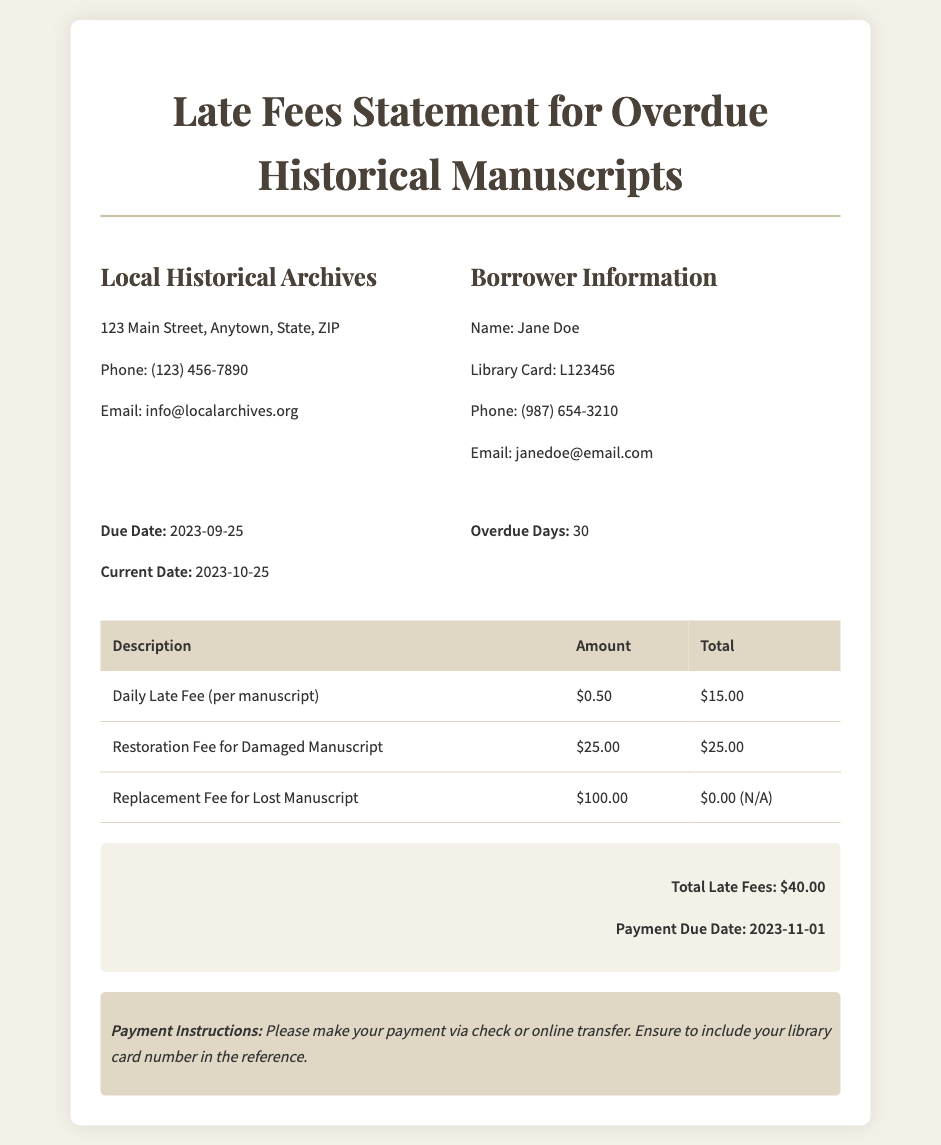What is the name of the borrower? The borrower is identified in the document as Jane Doe.
Answer: Jane Doe What is the total late fee amount? The total late fees are summarized at the end of the document, which is stated as $40.00.
Answer: $40.00 What is the due date for payment? The payment due date is given at the bottom of the document, which is 2023-11-01.
Answer: 2023-11-01 How many overdue days are noted? The document specifies that there are 30 overdue days for the borrowed manuscripts.
Answer: 30 What is the amount of the daily late fee per manuscript? The document lists the amount for the daily late fee as $0.50.
Answer: $0.50 What is the restoration fee for a damaged manuscript? The restoration fee for a damaged manuscript is detailed in the charges as $25.00.
Answer: $25.00 What is the phone number of the local archives? The contact information for the local archives includes a phone number, which is (123) 456-7890.
Answer: (123) 456-7890 How many manuscripts are being charged for the daily late fee? The total from the daily late fee calculation in the document indicates it is for 30 days, totaling $15.00 for one manuscript.
Answer: One manuscript What should be included in the payment reference? Instructions indicate that the library card number should be included in the payment reference.
Answer: Library card number 